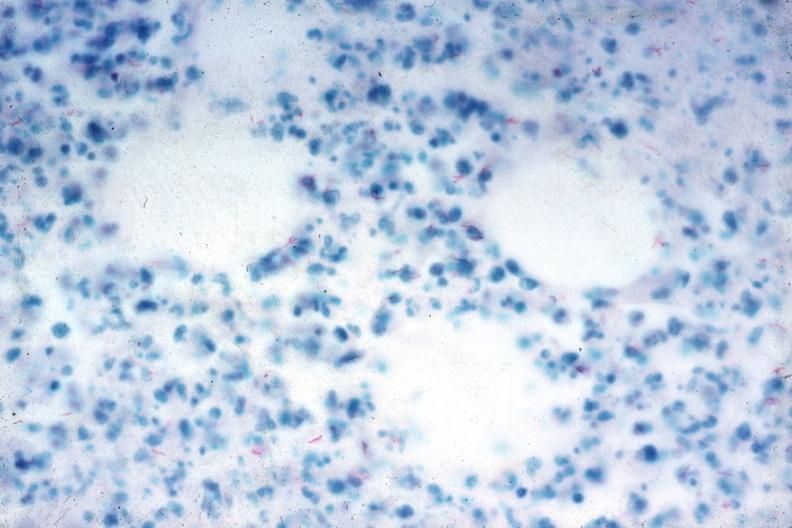what is present?
Answer the question using a single word or phrase. Tuberculosis 